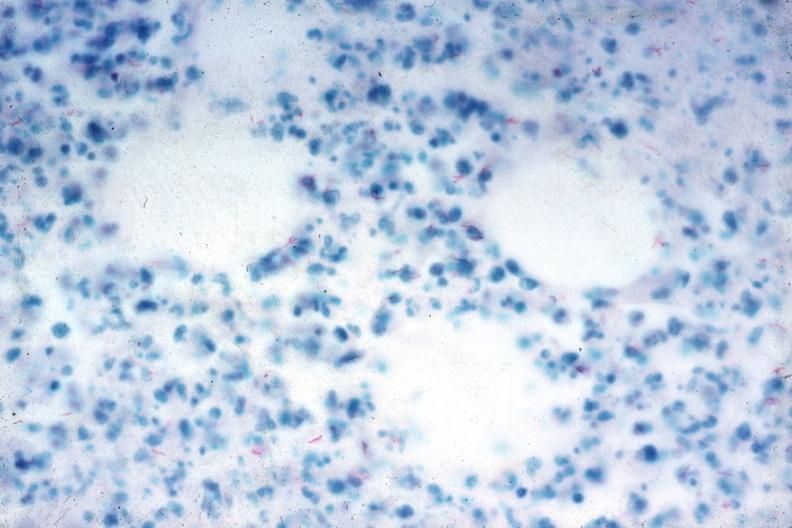what is present?
Answer the question using a single word or phrase. Tuberculosis 